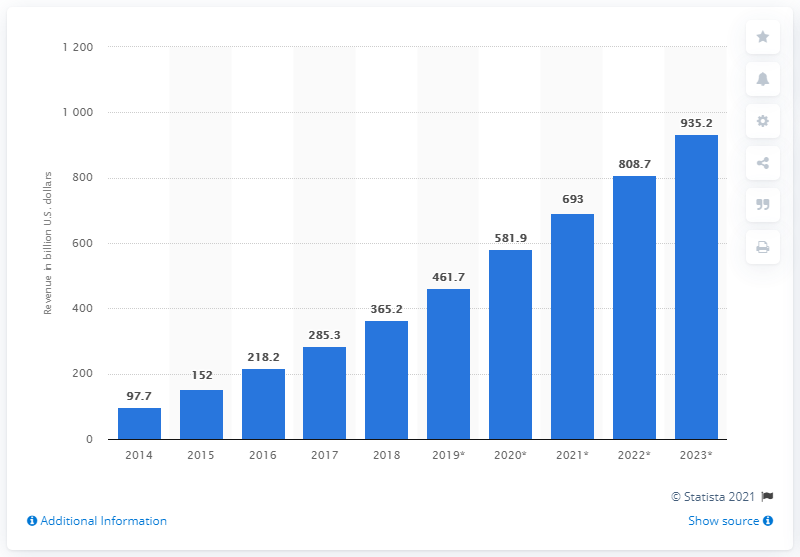Identify some key points in this picture. In 2018, the global mobile app revenues were $365.2 billion. According to projections, mobile apps are expected to generate significant revenue in 2023, with an estimated total of 935.2... 